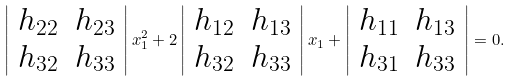Convert formula to latex. <formula><loc_0><loc_0><loc_500><loc_500>\left | \begin{array} { c c } h _ { 2 2 } & h _ { 2 3 } \\ h _ { 3 2 } & h _ { 3 3 } \end{array} \right | x _ { 1 } ^ { 2 } + 2 \left | \begin{array} { c c } h _ { 1 2 } & h _ { 1 3 } \\ h _ { 3 2 } & h _ { 3 3 } \end{array} \right | x _ { 1 } + \left | \begin{array} { c c } h _ { 1 1 } & h _ { 1 3 } \\ h _ { 3 1 } & h _ { 3 3 } \end{array} \right | = 0 .</formula> 